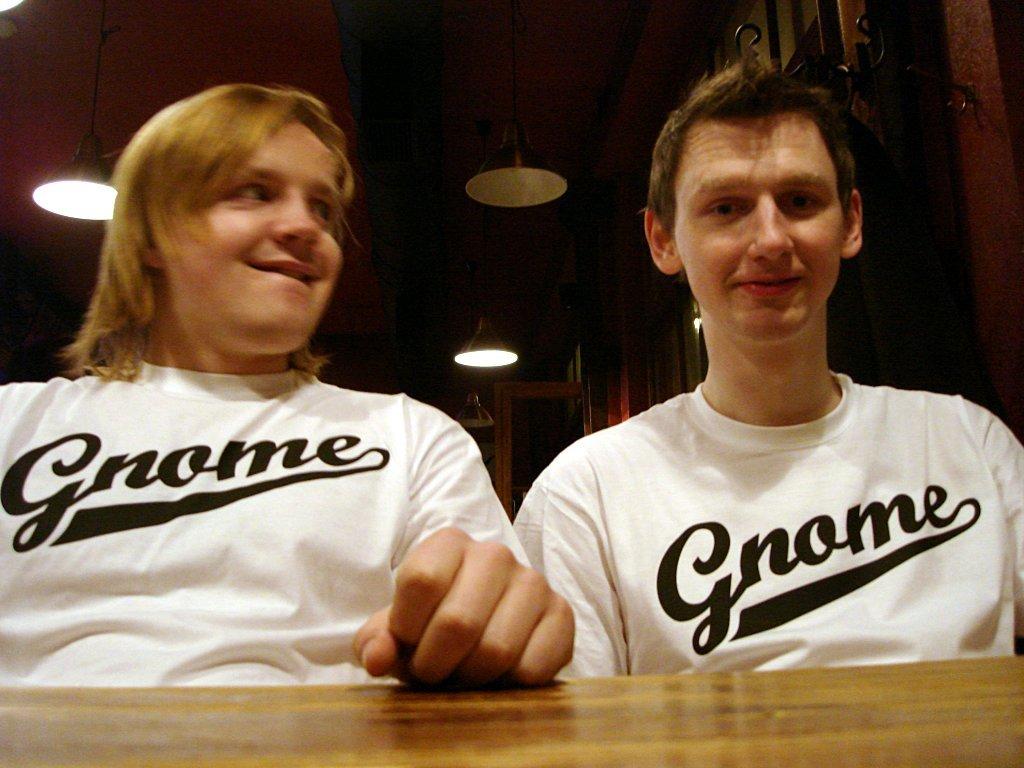Do these people prefer gnomes or dwarves?
Your answer should be compact. Gnome. What word is seen on both men's shirts?
Keep it short and to the point. Gnome. 